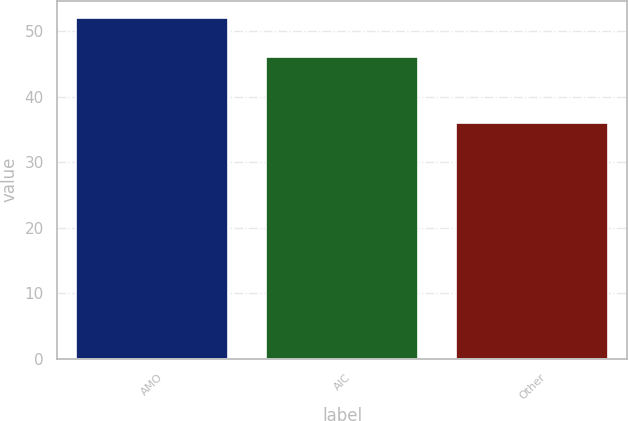Convert chart. <chart><loc_0><loc_0><loc_500><loc_500><bar_chart><fcel>AMO<fcel>AIC<fcel>Other<nl><fcel>52<fcel>46<fcel>36<nl></chart> 